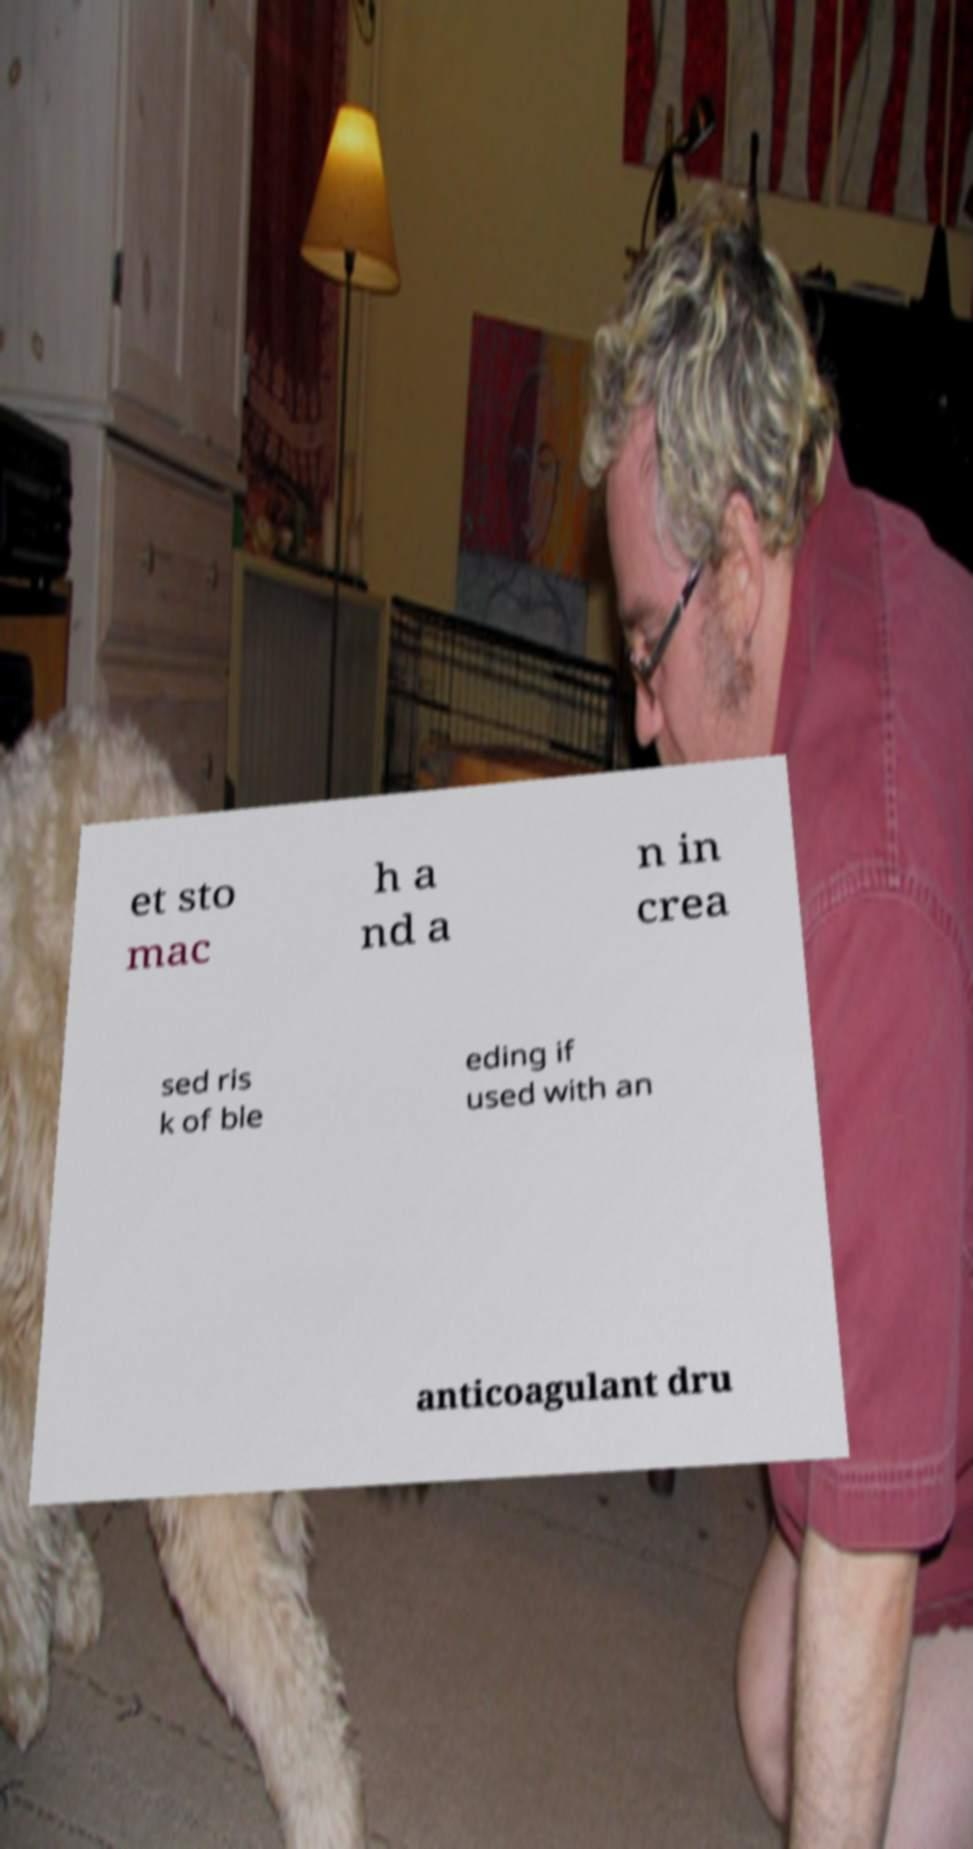Could you assist in decoding the text presented in this image and type it out clearly? et sto mac h a nd a n in crea sed ris k of ble eding if used with an anticoagulant dru 